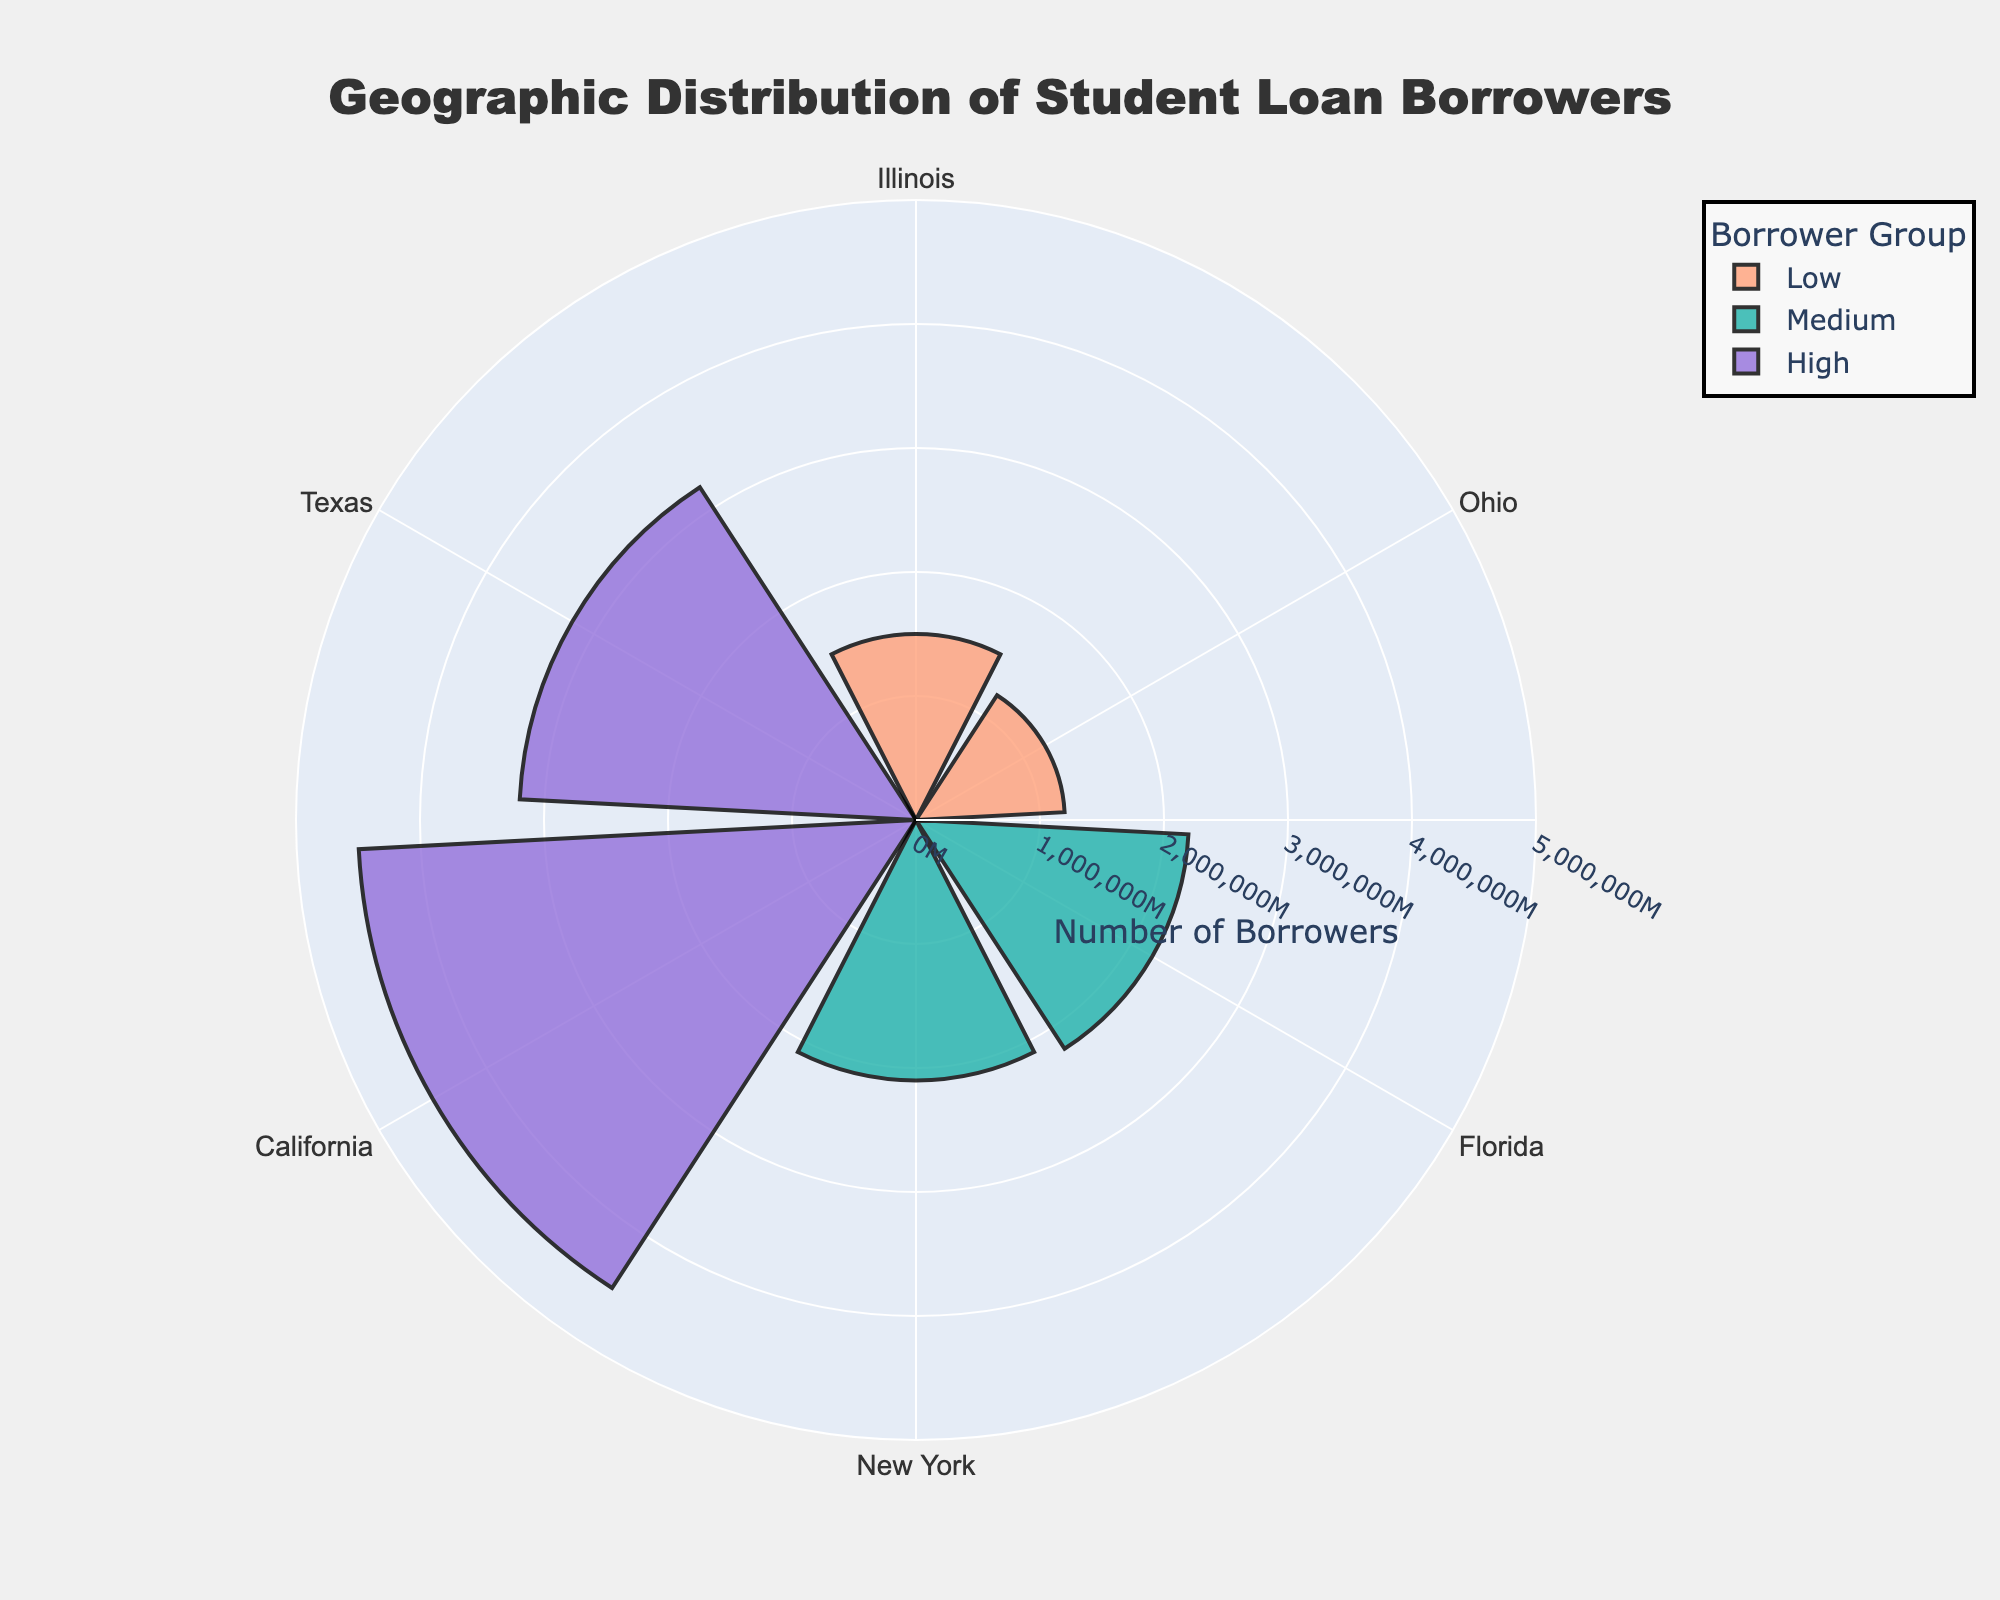Which state has the highest number of student loan borrowers? The state with the highest number of student loan borrowers can be identified by the longest bar in the "High" group. California has the longest bar in the "High" group, indicating the highest number of borrowers.
Answer: California What is the range of the radial axis? The range of the radial axis can be seen by looking at the labels on the radial axis in the rose chart. The range is from 0 to 5,000,000 borrowers.
Answer: 0 to 5,000,000 How many groups of borrowers are shown in the chart? The groups of borrowers are labeled by color and title in the legend. There are three groups: Low, Medium, and High.
Answer: Three Which 'Medium' group state has more student loan borrowers? Compare the 'Medium' group states by looking at the sizes of their bars. Florida has a longer bar in the 'Medium' group compared to New York, indicating more borrowers.
Answer: Florida What is the approximate difference in the number of borrowers between Texas and Ohio? Observing the bars for Texas and Ohio, Texas is in the "High" group with about 3,200,000 borrowers, and Ohio is in the "Low" group with about 1,200,000 borrowers. The difference is approximately 3,200,000 - 1,200,000 = 2,000,000.
Answer: 2,000,000 Which states fall under the 'Low' borrower group? The states in the 'Low' group are found by looking at the bars colored according to the 'Low' color in the legend. Illinois and Ohio fall under the 'Low' borrower group.
Answer: Illinois and Ohio What is the sum of borrowers in the 'Medium' group? Adding the number of borrowers for the 'Medium' group states: Florida (2,200,000) + New York (2,100,000) gives 4,300,000 borrowers in total.
Answer: 4,300,000 Which 'High' group state has fewer borrowers, California or Texas? Comparing the sizes of the bars for California and Texas in the 'High' group, Texas has a shorter bar indicating fewer borrowers.
Answer: Texas What color represents the 'High' borrower group on the rose chart? The ‘High’ group can be identified by its label in the legend and the corresponding color. The color for the 'High' group is purple.
Answer: Purple How many states are represented in the chart? Count the unique states listed on the angular axis of the chart. There are six states in total.
Answer: Six 